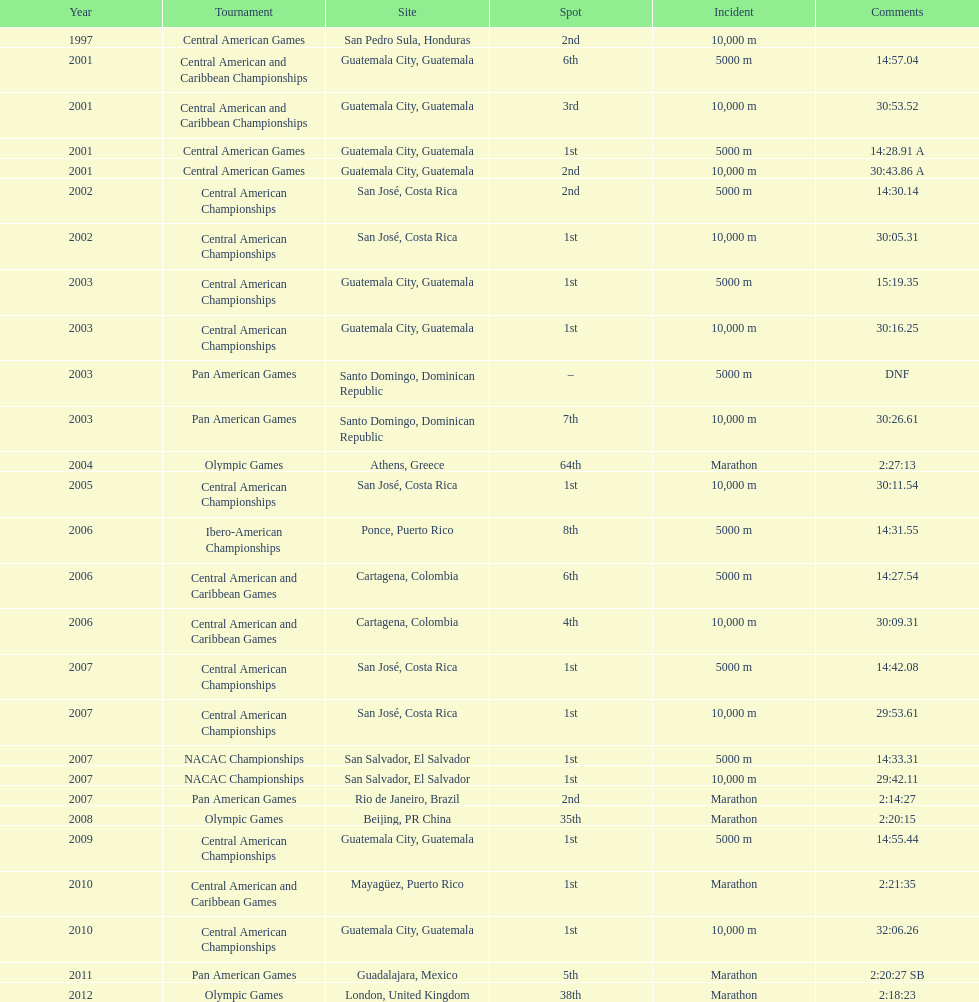Where was the only 64th position held? Athens, Greece. 